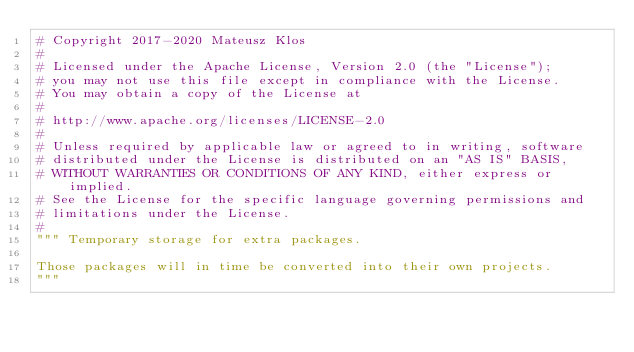<code> <loc_0><loc_0><loc_500><loc_500><_Python_># Copyright 2017-2020 Mateusz Klos
#
# Licensed under the Apache License, Version 2.0 (the "License");
# you may not use this file except in compliance with the License.
# You may obtain a copy of the License at
#
# http://www.apache.org/licenses/LICENSE-2.0
#
# Unless required by applicable law or agreed to in writing, software
# distributed under the License is distributed on an "AS IS" BASIS,
# WITHOUT WARRANTIES OR CONDITIONS OF ANY KIND, either express or implied.
# See the License for the specific language governing permissions and
# limitations under the License.
#
""" Temporary storage for extra packages.

Those packages will in time be converted into their own projects.
"""
</code> 